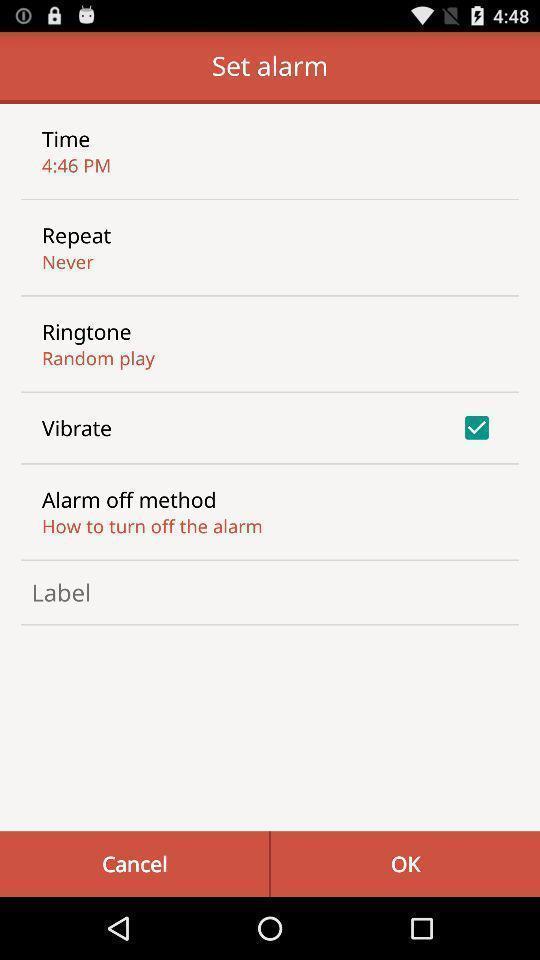Explain the elements present in this screenshot. Screen displaying list of options under set alarm. 